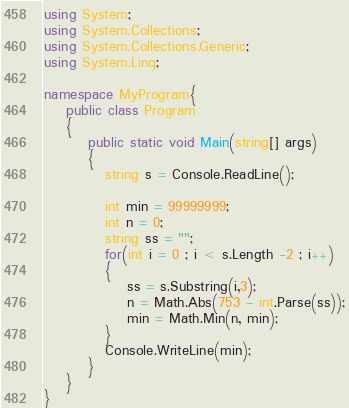<code> <loc_0><loc_0><loc_500><loc_500><_C#_>using System;
using System.Collections;
using System.Collections.Generic;
using System.Linq;

namespace MyProgram{
    public class Program
    {	
        public static void Main(string[] args)
    	{
           string s = Console.ReadLine();
           
           int min = 99999999;
           int n = 0;
           string ss = "";
           for(int i = 0 ; i < s.Length -2 ; i++)
           {
               ss = s.Substring(i,3);
               n = Math.Abs(753 - int.Parse(ss));
               min = Math.Min(n, min);
           }
           Console.WriteLine(min);
    	}
    }
}</code> 